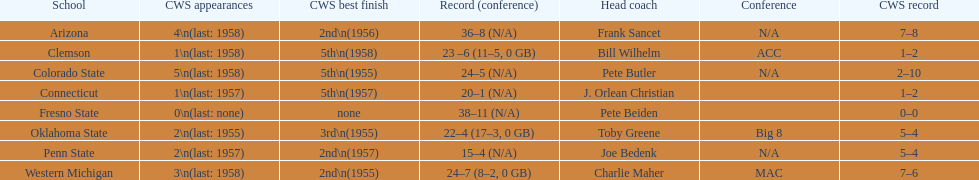Write the full table. {'header': ['School', 'CWS appearances', 'CWS best finish', 'Record (conference)', 'Head coach', 'Conference', 'CWS record'], 'rows': [['Arizona', '4\\n(last: 1958)', '2nd\\n(1956)', '36–8 (N/A)', 'Frank Sancet', 'N/A', '7–8'], ['Clemson', '1\\n(last: 1958)', '5th\\n(1958)', '23 –6 (11–5, 0 GB)', 'Bill Wilhelm', 'ACC', '1–2'], ['Colorado State', '5\\n(last: 1958)', '5th\\n(1955)', '24–5 (N/A)', 'Pete Butler', 'N/A', '2–10'], ['Connecticut', '1\\n(last: 1957)', '5th\\n(1957)', '20–1 (N/A)', 'J. Orlean Christian', '', '1–2'], ['Fresno State', '0\\n(last: none)', 'none', '38–11 (N/A)', 'Pete Beiden', '', '0–0'], ['Oklahoma State', '2\\n(last: 1955)', '3rd\\n(1955)', '22–4 (17–3, 0 GB)', 'Toby Greene', 'Big 8', '5–4'], ['Penn State', '2\\n(last: 1957)', '2nd\\n(1957)', '15–4 (N/A)', 'Joe Bedenk', 'N/A', '5–4'], ['Western Michigan', '3\\n(last: 1958)', '2nd\\n(1955)', '24–7 (8–2, 0 GB)', 'Charlie Maher', 'MAC', '7–6']]} Oklahoma state and penn state both have how many cws appearances? 2. 